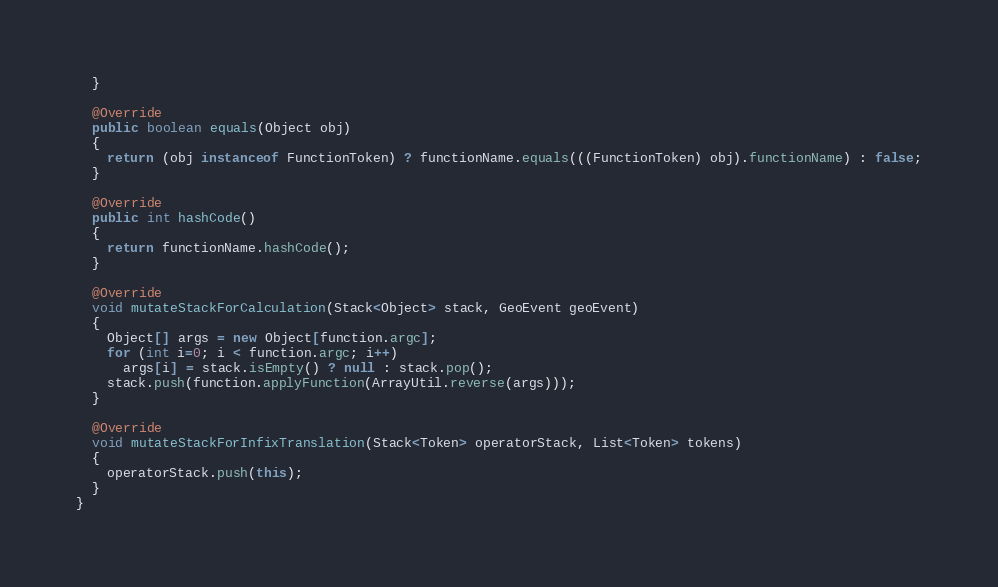<code> <loc_0><loc_0><loc_500><loc_500><_Java_>  }

  @Override
  public boolean equals(Object obj)
  {
    return (obj instanceof FunctionToken) ? functionName.equals(((FunctionToken) obj).functionName) : false;
  }

  @Override
  public int hashCode()
  {
    return functionName.hashCode();
  }

  @Override
  void mutateStackForCalculation(Stack<Object> stack, GeoEvent geoEvent)
  {
    Object[] args = new Object[function.argc];
    for (int i=0; i < function.argc; i++)
      args[i] = stack.isEmpty() ? null : stack.pop();
    stack.push(function.applyFunction(ArrayUtil.reverse(args)));
  }
  
  @Override
  void mutateStackForInfixTranslation(Stack<Token> operatorStack, List<Token> tokens)
  {
    operatorStack.push(this);
  }
}</code> 